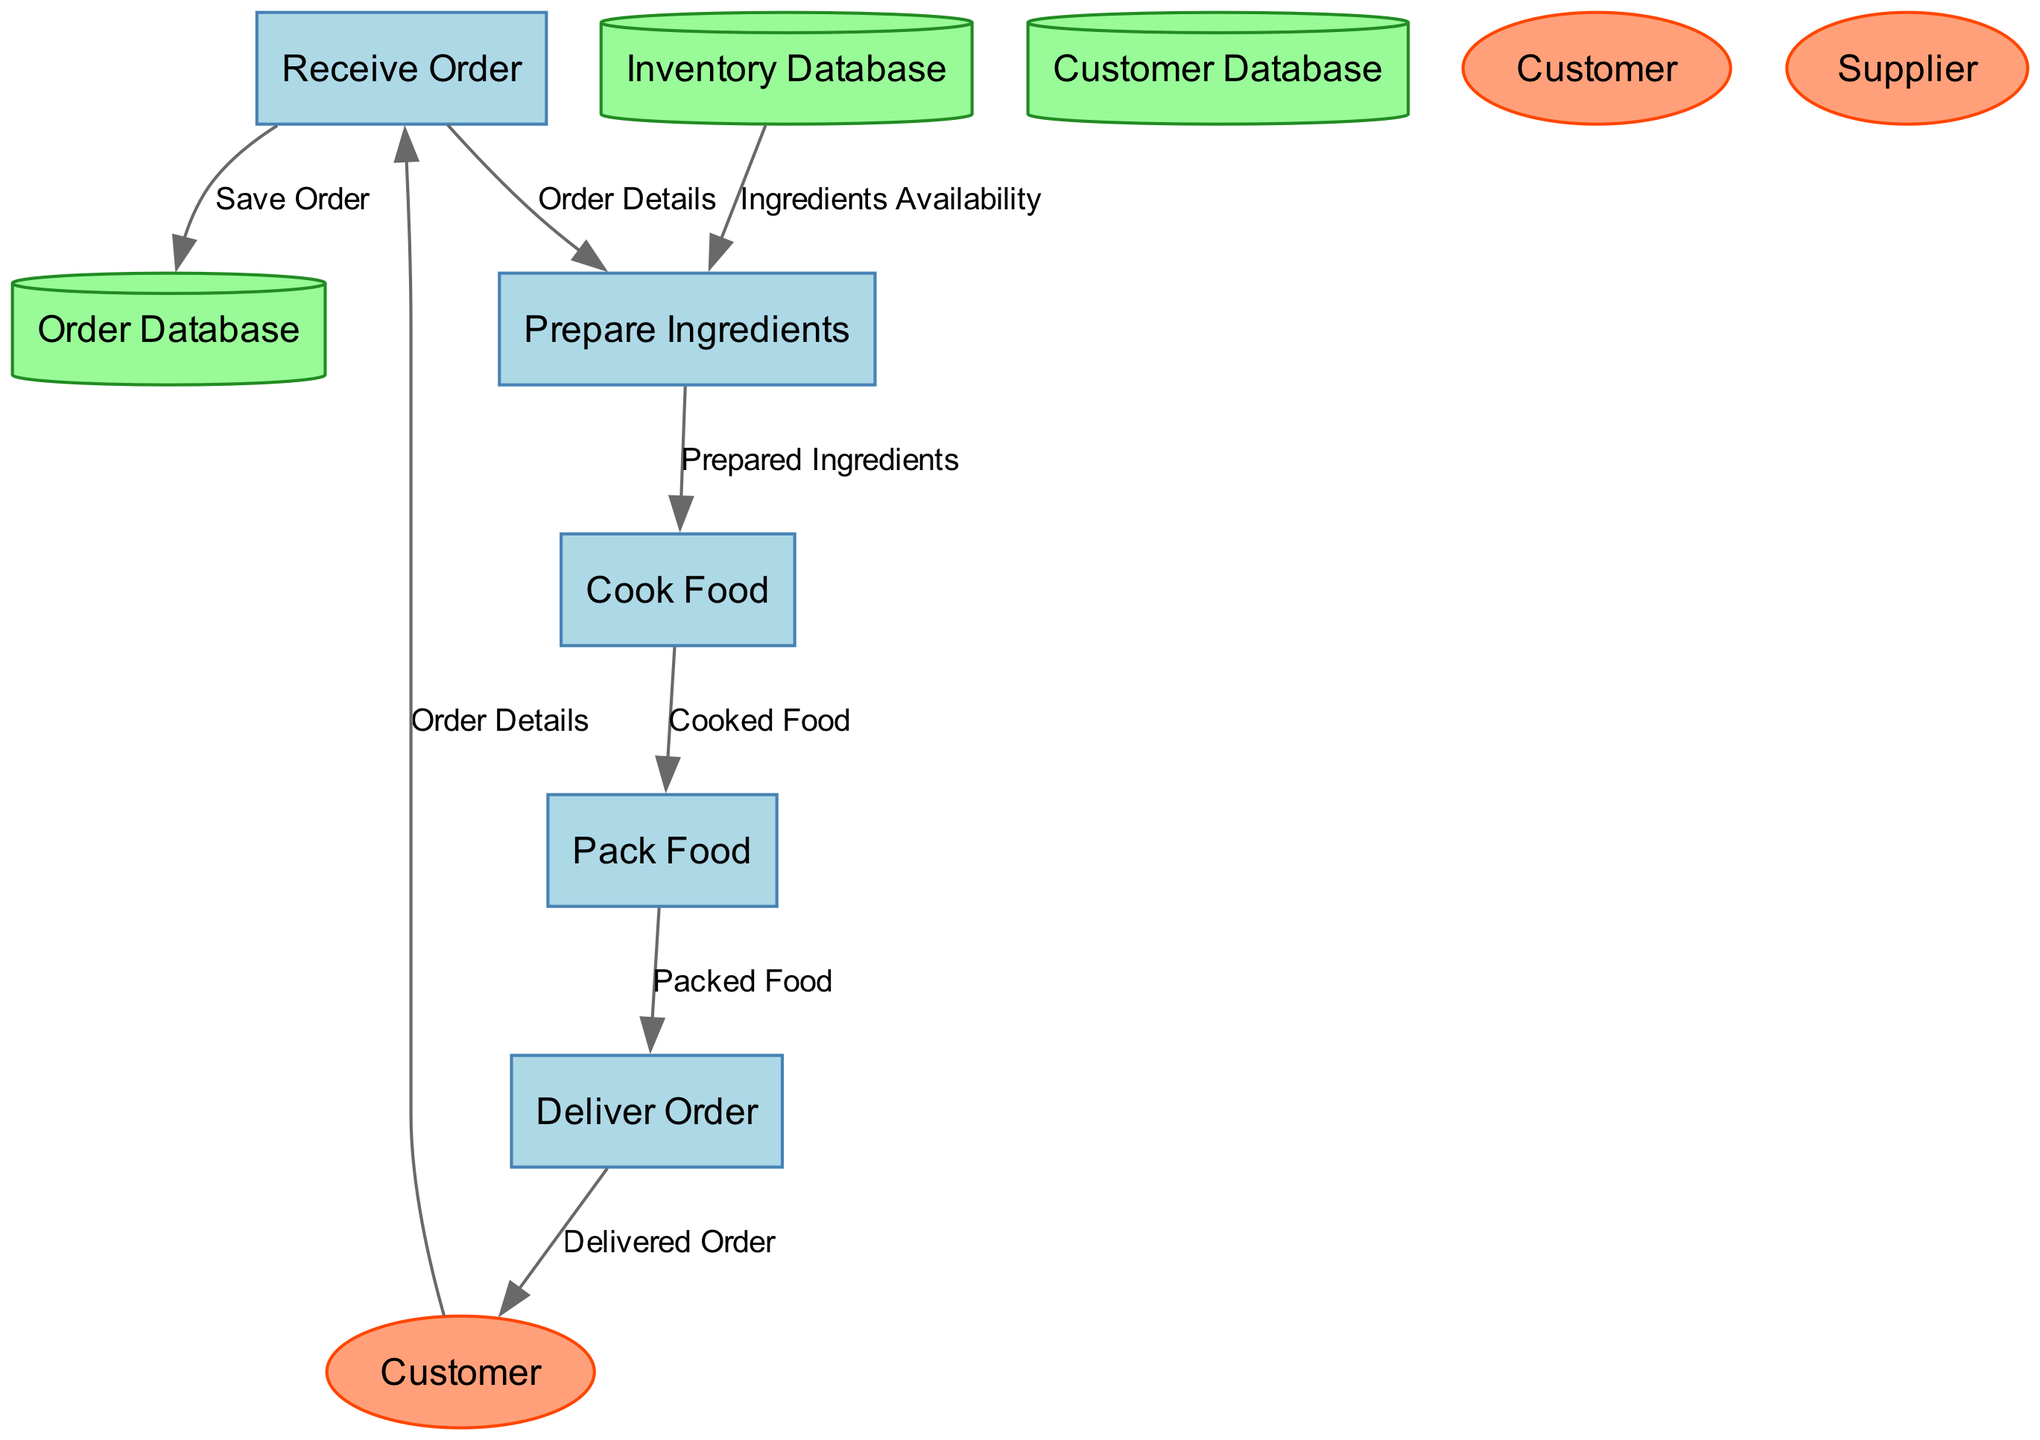What is the first process in the diagram? The first process in the diagram is labeled as "P1", which corresponds to "Receive Order". This is the starting point where the customer places their order.
Answer: Receive Order How many data stores are present in the diagram? The diagram shows three data stores labeled "Order Database", "Inventory Database", and "Customer Database". Counting these, we arrive at a total of three data stores.
Answer: 3 What does the "Cook Food" process output? The "Cook Food" process is labeled as "P3". Its output is described as "Cooked Food", which is then passed to the next process "Pack Food".
Answer: Cooked Food Which external entity interacts with the "Deliver Order" process? The "Deliver Order" process, labeled as "P5", has a direct interaction with the "Customer", who is the recipient of the delivered food.
Answer: Customer What is the data flow from the "Prepare Ingredients" process to the "Cook Food" process? The data flow from "Prepare Ingredients", labeled as "P2", to "Cook Food", labeled as "P3", consists of "Prepared Ingredients". This indicates the input for cooking.
Answer: Prepared Ingredients Which process follows after the "Pack Food" process? The process following "Pack Food", labeled as "P4", is "Deliver Order", labeled as "P5". This transition shows the packed food being sent out for delivery or pickup.
Answer: Deliver Order What type of information is stored in the "Order Database"? The "Order Database" stores details regarding customer orders, including menu items, special requests, and delivery instructions. This database is accessed during the ordering process.
Answer: Order details What is the relationship between "Cook Food" and "Pack Food"? The relationship between "Cook Food" (P3) and "Pack Food" (P4) is that "Cook Food" outputs "Cooked Food", which becomes the input for "Pack Food". This flow shows the progression from cooking to packing.
Answer: Cooked Food What is the purpose of the "Inventory Database"? The "Inventory Database" serves to hold information about available ingredients and stock levels. This helps in ensuring that the preparation process can access necessary ingredients.
Answer: Available ingredients 